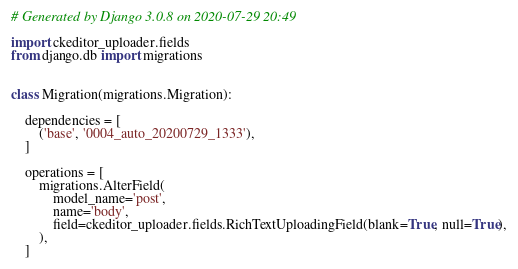Convert code to text. <code><loc_0><loc_0><loc_500><loc_500><_Python_># Generated by Django 3.0.8 on 2020-07-29 20:49

import ckeditor_uploader.fields
from django.db import migrations


class Migration(migrations.Migration):

    dependencies = [
        ('base', '0004_auto_20200729_1333'),
    ]

    operations = [
        migrations.AlterField(
            model_name='post',
            name='body',
            field=ckeditor_uploader.fields.RichTextUploadingField(blank=True, null=True),
        ),
    ]
</code> 